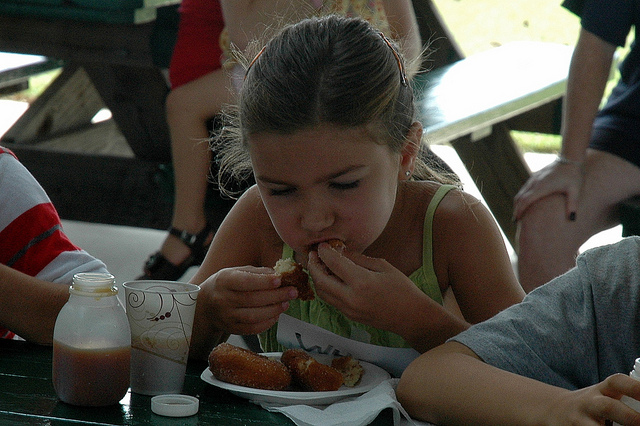Can you tell me more about the setting? Certainly. The image shows an outdoor eating area, likely at a park or an event venue. There is a green picnic table, and we can imply a casual, communal atmosphere, possibly during a community event or family outing. 